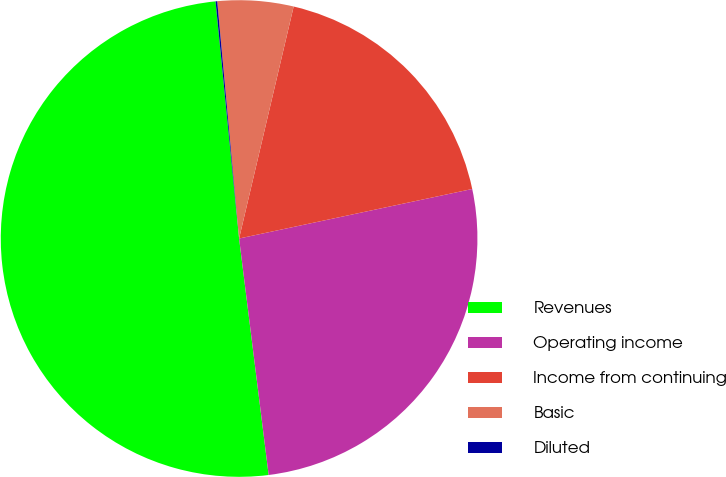Convert chart. <chart><loc_0><loc_0><loc_500><loc_500><pie_chart><fcel>Revenues<fcel>Operating income<fcel>Income from continuing<fcel>Basic<fcel>Diluted<nl><fcel>50.4%<fcel>26.35%<fcel>17.99%<fcel>5.14%<fcel>0.11%<nl></chart> 